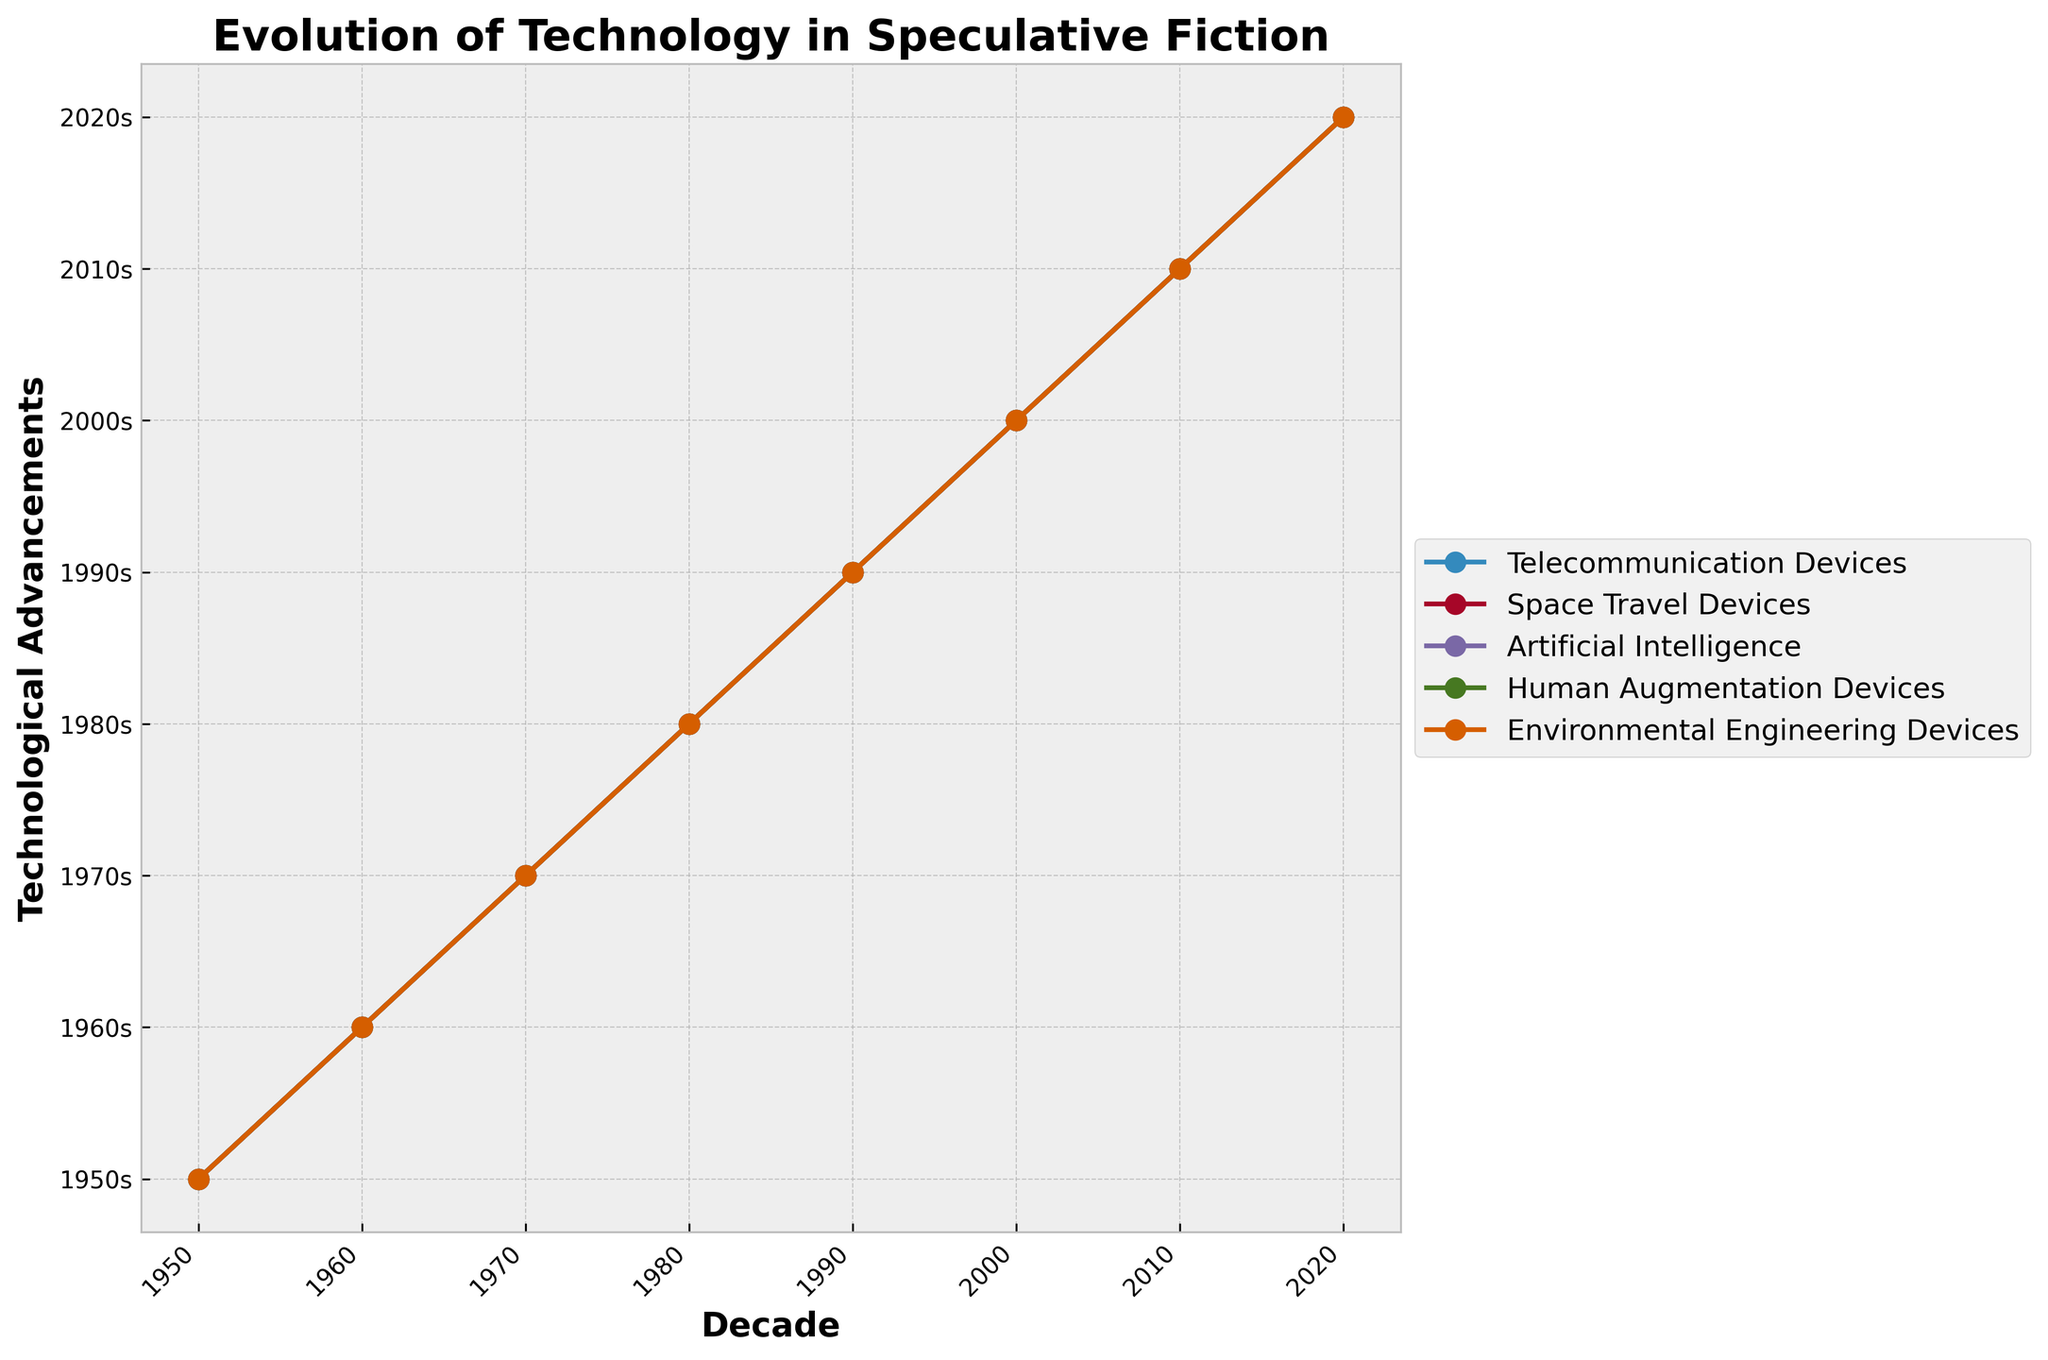What is the title of the figure? The title is usually displayed prominently at the top of the figure. Here, it reads 'Evolution of Technology in Speculative Fiction'.
Answer: Evolution of Technology in Speculative Fiction Which decade features "CRISPR Gene Editing" as a technological advancement? Look at the 'Human Augmentation Devices' markers along the time axis to find when "CRISPR Gene Editing" is listed. It appears in the 2010s.
Answer: 2010s How many technological categories are tracked in the figure? Count the number of unique lines or legend entries to determine the number of categories. There are 5: Telecommunication Devices, Space Travel Devices, Artificial Intelligence, Human Augmentation Devices, and Environmental Engineering Devices.
Answer: 5 Which decade first introduced "Machine Learning Systems"? Check the 'Artificial Intelligence' category and find when "Machine Learning Systems" first appears. It can be seen in the 2000s.
Answer: 2000s Compare the technological advancement in the 'Telecommunication Devices' category from the 1950s to the 2020s. What is the trend? The series shows that starting from radio communicators (1950s), the technology evolves to wearable smart devices (2020s) over time, indicating a shift from basic communication tools to more integrated and advanced devices. To summarize, the trend indicates a significant technological progression.
Answer: Advancing Which category has shown a greater variety of different devices, 'Space Travel Devices' or 'Environmental Engineering Devices'? Count the different unique advancements listed in the 'Space Travel Devices' and 'Environmental Engineering Devices' over the decades. 'Space Travel Devices' have: Atomic Rocketships, Moon Landers, Space Shuttles, Space Stations, Mars Rovers, Commercial Spacecraft, Space Tourism Ships, and Interplanetary Ships (8). 'Environmental Engineering Devices' have: Underwater Cities, Climate Control Domes, Orbital Habitats, Geo-engineering Machines, Garden Cities, Renewable Energy Arrays, Artificial Islands, and Carbon Capture Facilities (8). Both categories show an equal variety of 8 different devices.
Answer: Equal In which decade did 'Artificial Intelligence' start featuring 'General AI'? Look at the progression of the 'Artificial Intelligence' category to find when "General AI" appears. It is seen in the 2020s.
Answer: 2020s Calculate the median year when 'Space Travel Devices' advancements were introduced. The years for 'Space Travel Devices' are the decades: 1950s, 1960s, 1970s, 1980s, 1990s, 2000s, 2010s, and 2020s. Ordering them numerically: 1950, 1960, 1970, 1980, 1990, 2000, 2010, and 2020. The median is the middle value of the ordered list, which is between 1980 and 1990, so the median year is 1985.
Answer: 1985 Which technological category had the first advancement recorded in the 1960s? Look for the first markers in the decade of the 1960s and identify the corresponding category. 'Portable Televisors' in the 'Telecommunication Devices' category appear among the earliest in the 1960s.
Answer: Telecommunication Devices 